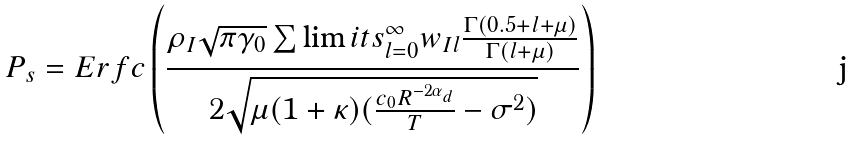<formula> <loc_0><loc_0><loc_500><loc_500>P _ { s } = E r f c \left ( \frac { \rho _ { I } \sqrt { \pi \gamma _ { 0 } } \sum \lim i t s _ { l = 0 } ^ { \infty } w _ { I l } \frac { \Gamma ( 0 . 5 + l + \mu ) } { \Gamma ( l + \mu ) } } { 2 \sqrt { \mu ( 1 + \kappa ) ( \frac { c _ { 0 } R ^ { - 2 \alpha _ { d } } } { T } - \sigma ^ { 2 } ) } } \right )</formula> 